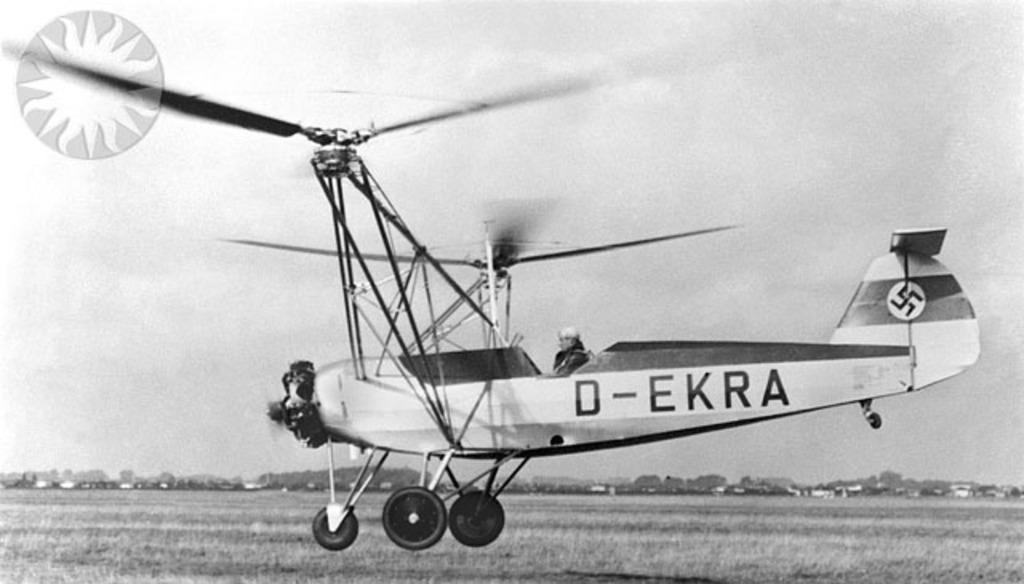What is the main subject of the image? The main subject of the image is an airplane. Where is the airplane located in the image? The airplane is in the air above the ground. What is the color scheme of the image? The image is in black and white. What can be seen in the background of the image? There is the sky visible in the background of the image. How many fish can be seen swimming in the image? There are no fish present in the image; it features an airplane in the sky. What type of horses are depicted in the image? There are no horses present in the image; it features an airplane in the sky. 